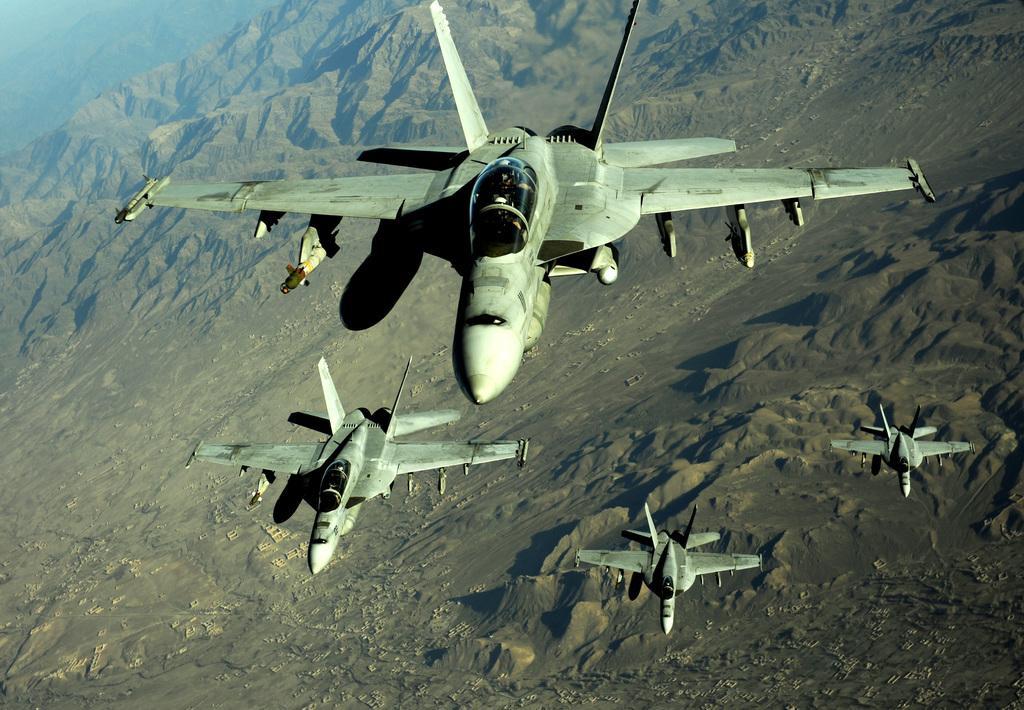Could you give a brief overview of what you see in this image? In this image in the center there are some aircrafts, and in the background there are some mountains and sand. 